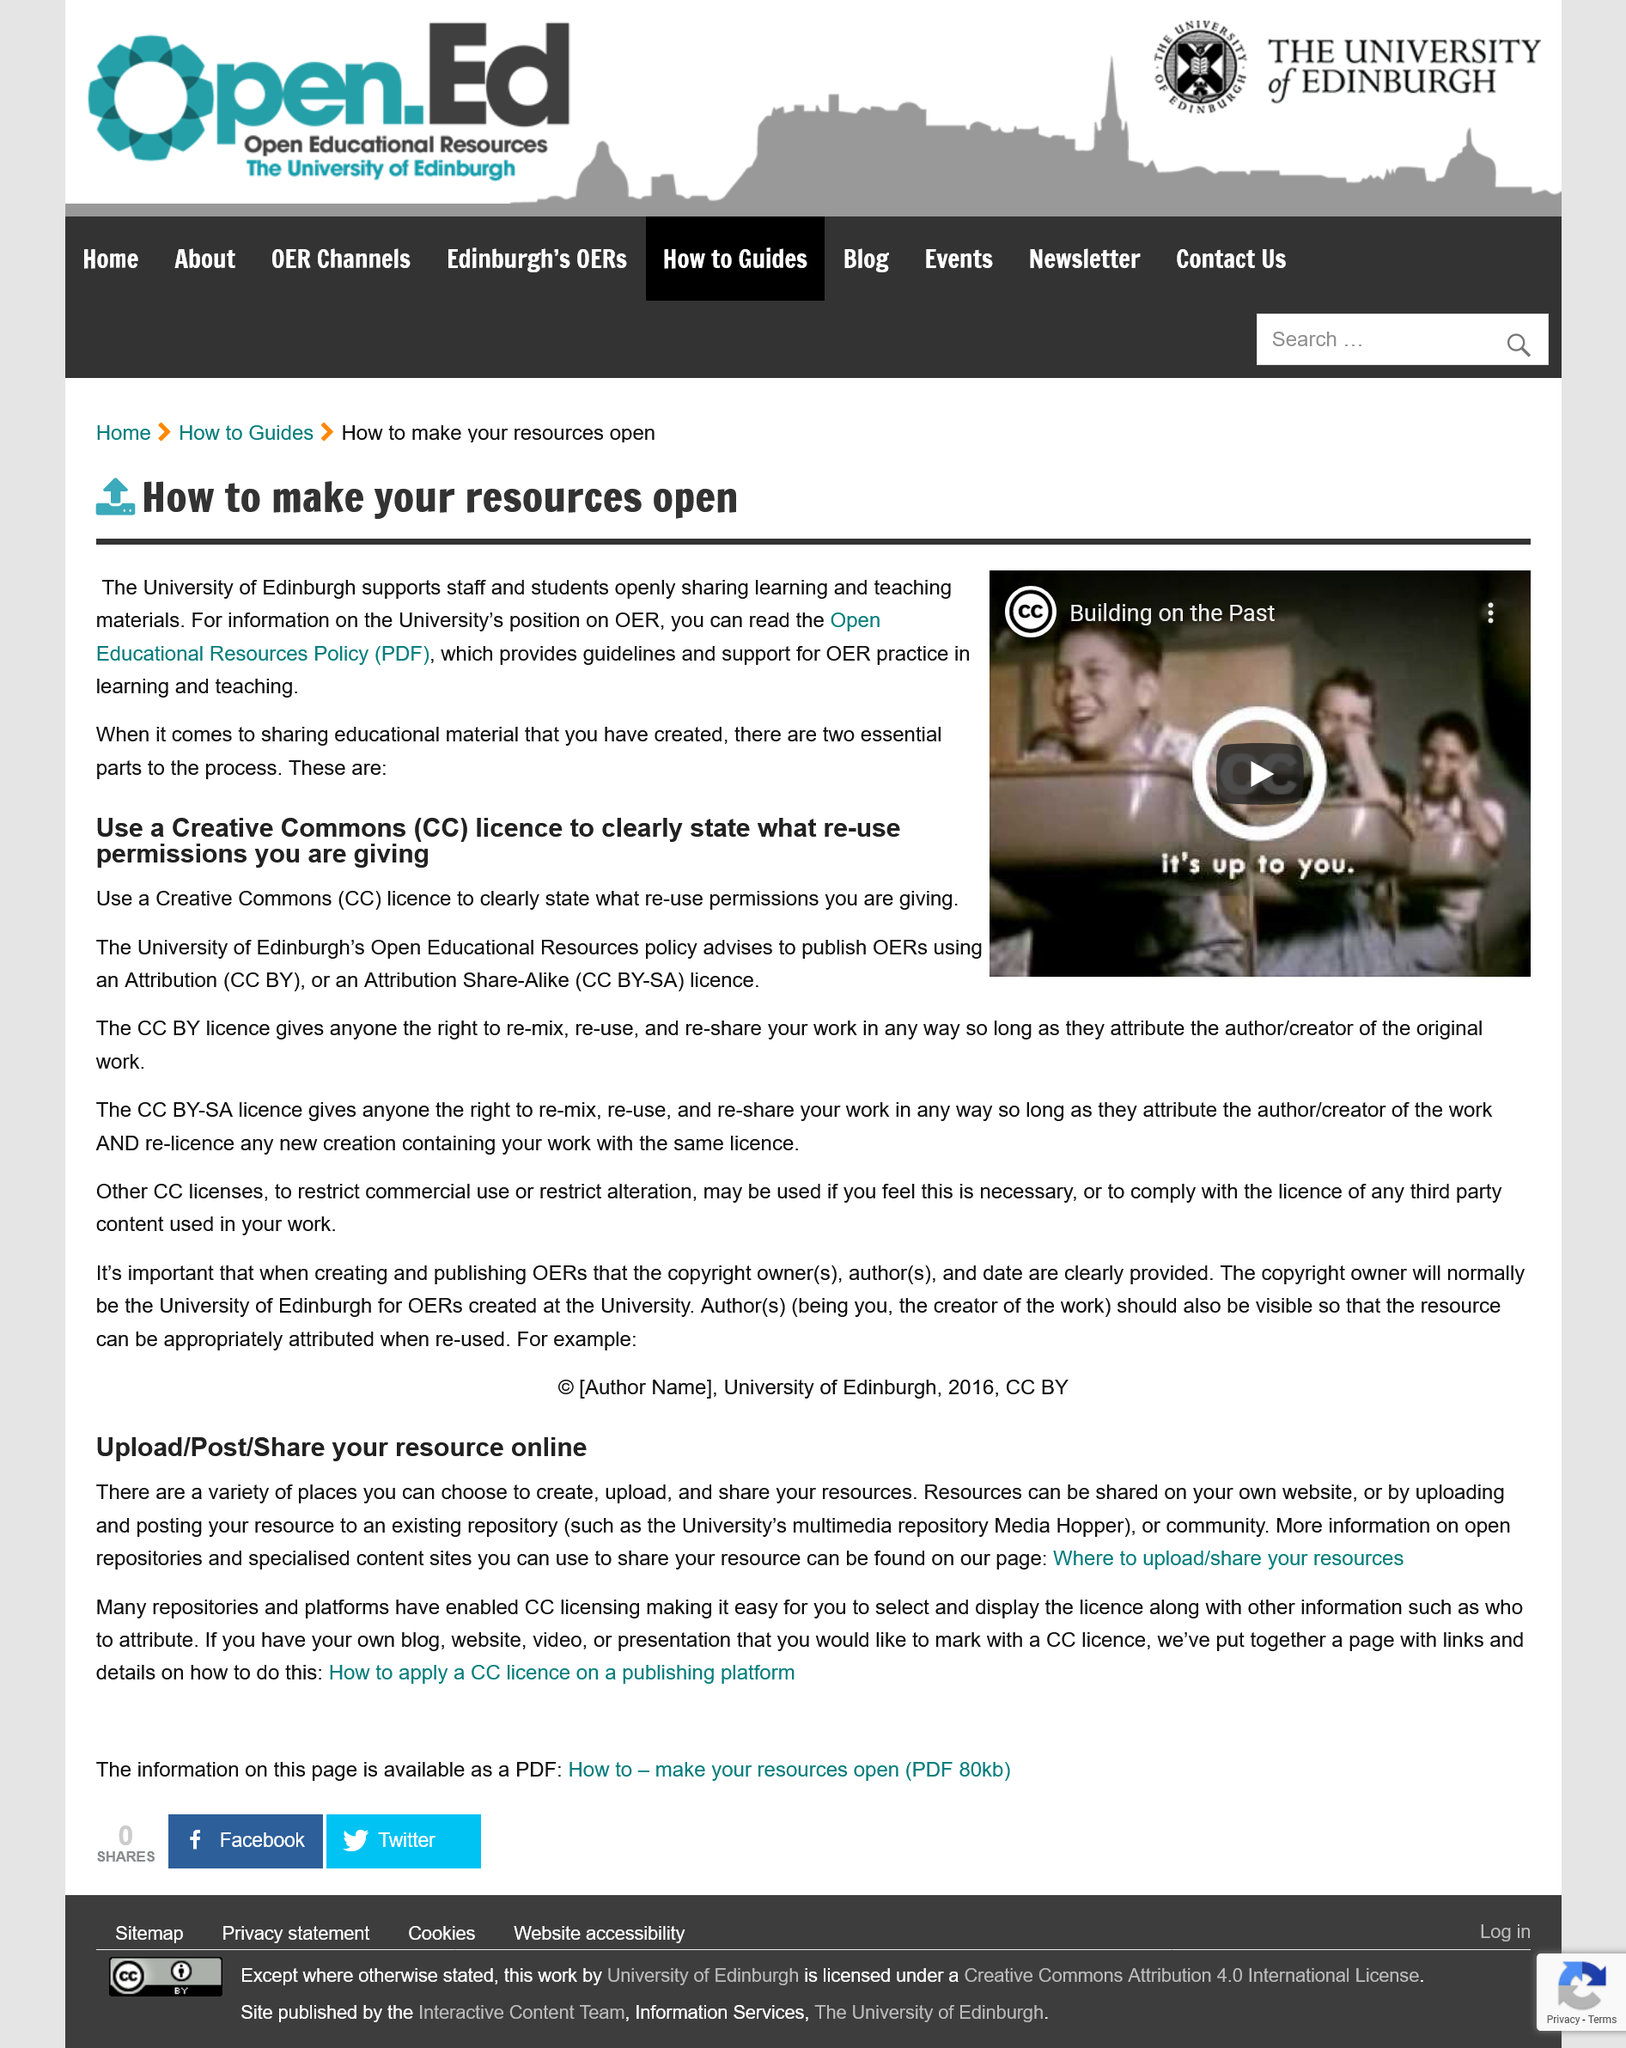Draw attention to some important aspects in this diagram. The University of Edinburgh owns the Open Educational Resources (OERs) created by the university. The University's multimedia repository, Media Hopper, is provided as an existing example of a repository. Two different types of Creative Commons (CC) licenses are mentioned in the text. This article provides links on where to upload resources and how to make resources PDF. Resources can be shared on one's own website, as confirmed. 